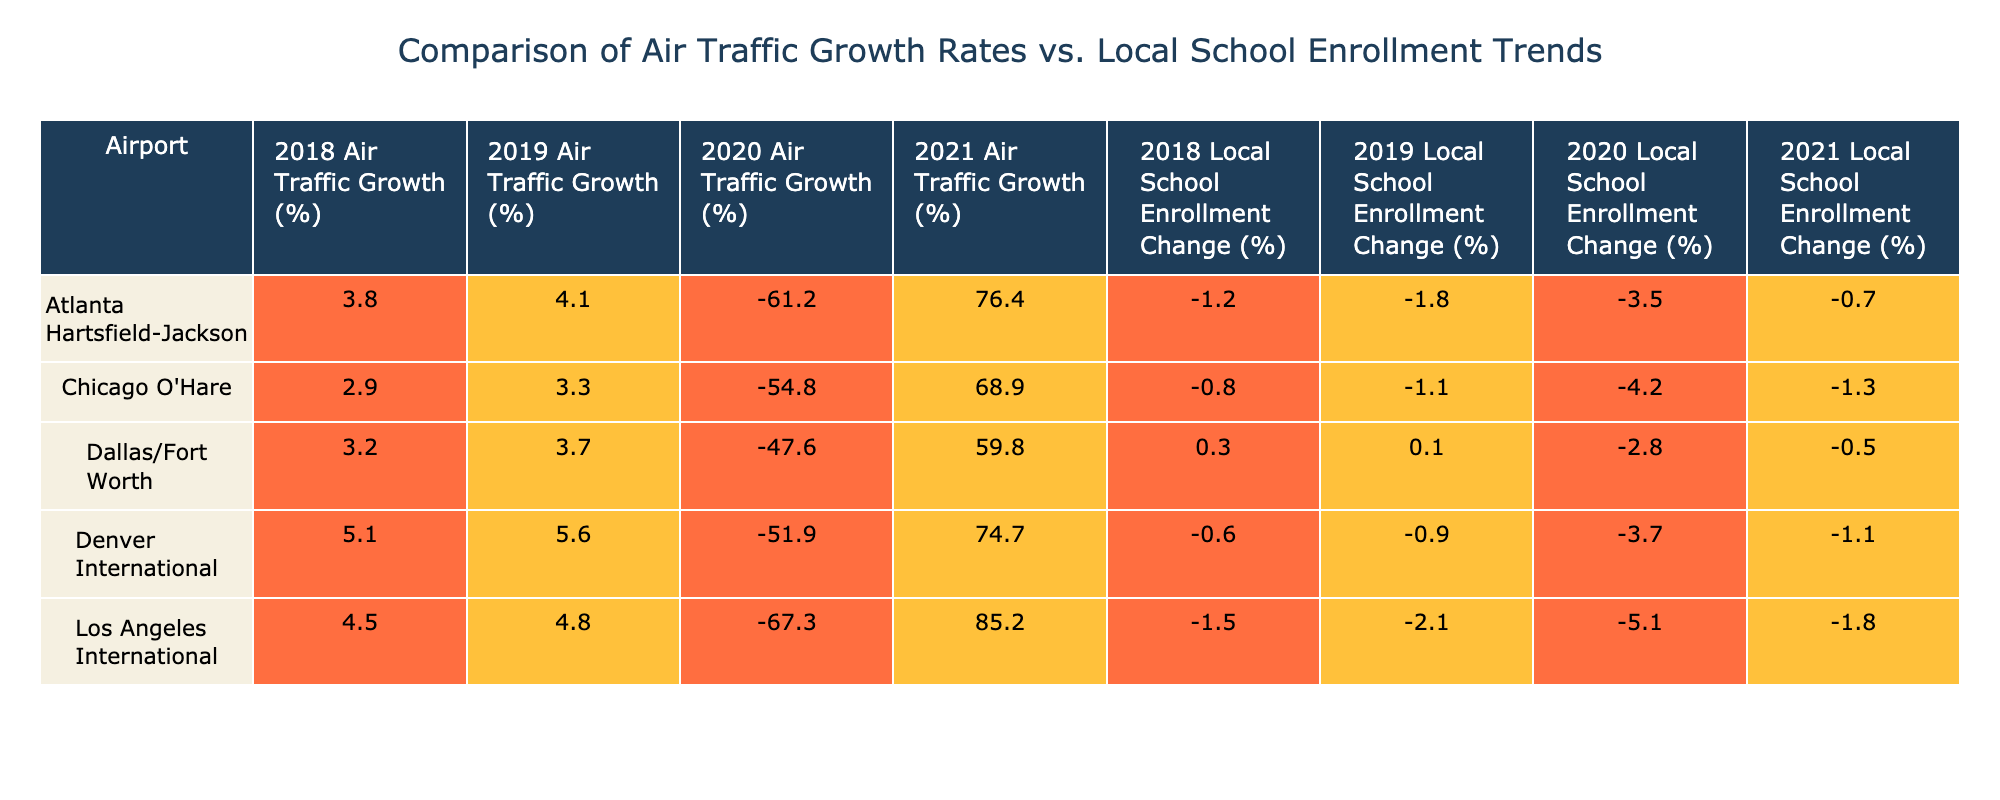What is the air traffic growth percentage for Los Angeles International in 2021? According to the table, in 2021, the air traffic growth percentage for Los Angeles International is listed as 85.2%.
Answer: 85.2% What was the change in local school enrollment at Chicago O'Hare from 2018 to 2021? In 2018, the change in local school enrollment at Chicago O'Hare was -0.8%, and in 2021 it was -1.3%. To find the change, we subtract: -1.3% - (-0.8%) = -0.5%.
Answer: -0.5% Which airport had the highest increase in air traffic growth from 2020 to 2021? Looking at the air traffic growth in 2020, all airports had negative growth rates. In 2021, all airports showed positive growth. The increases are 76.4% (Atlanta), 68.9% (Chicago), 85.2% (Los Angeles), 59.8% (Dallas), and 74.7% (Denver). Here, Los Angeles International had the highest increase of 85.2%.
Answer: Los Angeles International Was there a positive change in local school enrollment at Dallas/Fort Worth in 2019? In 2019, the local school enrollment change at Dallas/Fort Worth was 0.1%, which is positive.
Answer: Yes What is the average air traffic growth rate for Atlanta Hartsfield-Jackson over the years presented? The air traffic growth rates for Atlanta Hartsfield-Jackson are: 3.8%, 4.1%, -61.2%, 76.4%. We sum them up: (3.8 + 4.1 - 61.2 + 76.4) = 23.1%. There are 4 data points, so the average is 23.1% / 4 = 5.775%.
Answer: 5.78% Which airport had the largest decline in local school enrollment change from 2018 to 2020? The table shows changes in school enrollment for each of the five airports. Comparing their values from 2018 to 2020, Atlanta's change decreased from -1.2% to -3.5% (a decline of -2.3%), Chicago from -0.8% to -4.2% (decline of -3.4%), Los Angeles from -1.5% to -5.1% (decline of -3.6%), Dallas from 0.3% to -2.8% (decline of -3.1%), and Denver from -0.6% to -3.7% (decline of -3.1%). The largest decline is for Los Angeles International, which declined by 3.6%.
Answer: Los Angeles International What was the overall change in local school enrollment from 2018 to 2021 for Denver International? For Denver International, local school enrollment changed from -0.6% in 2018 to -1.1% in 2021. To find the overall change, we subtract: -1.1% - (-0.6%) = -0.5%.
Answer: -0.5% Is it true that none of the airports had a positive local school enrollment change in 2020? Looking at the table, all airports have negative values for local school enrollment change in 2020. Therefore, it is true that none had a positive change.
Answer: True 